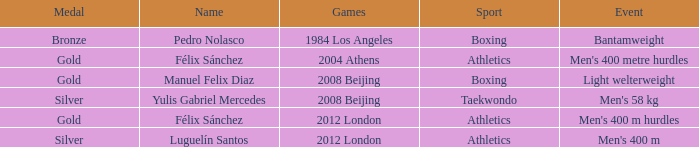Which Medal had a Games of 2008 beijing, and a Sport of taekwondo? Silver. 